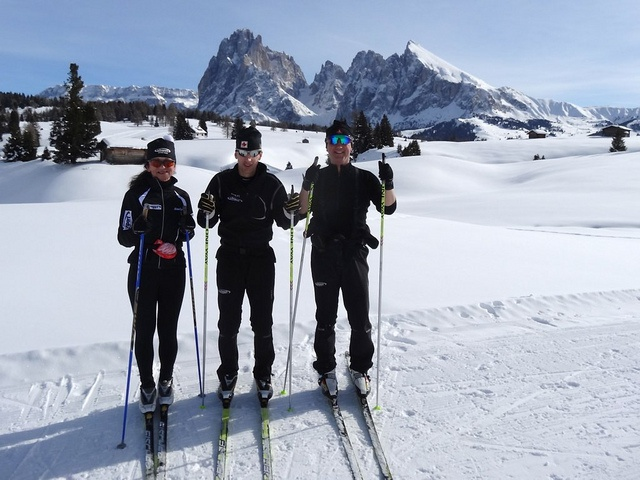Describe the objects in this image and their specific colors. I can see people in darkgray, black, lightgray, and gray tones, people in darkgray, black, gray, and maroon tones, people in darkgray, black, lavender, gray, and navy tones, skis in darkgray, gray, lightgray, and black tones, and skis in darkgray, gray, blue, and darkgreen tones in this image. 